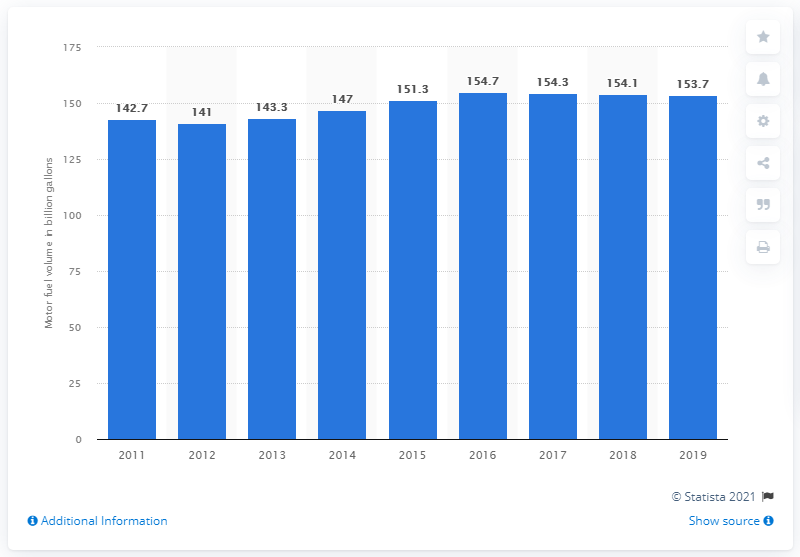Indicate a few pertinent items in this graphic. In 2019, the sales of motor fuel at convenience stores in the United States totaled 153.7 billion liters. 